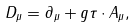Convert formula to latex. <formula><loc_0><loc_0><loc_500><loc_500>D _ { \mu } = \partial _ { \mu } + g \tau \cdot A _ { \mu } ,</formula> 